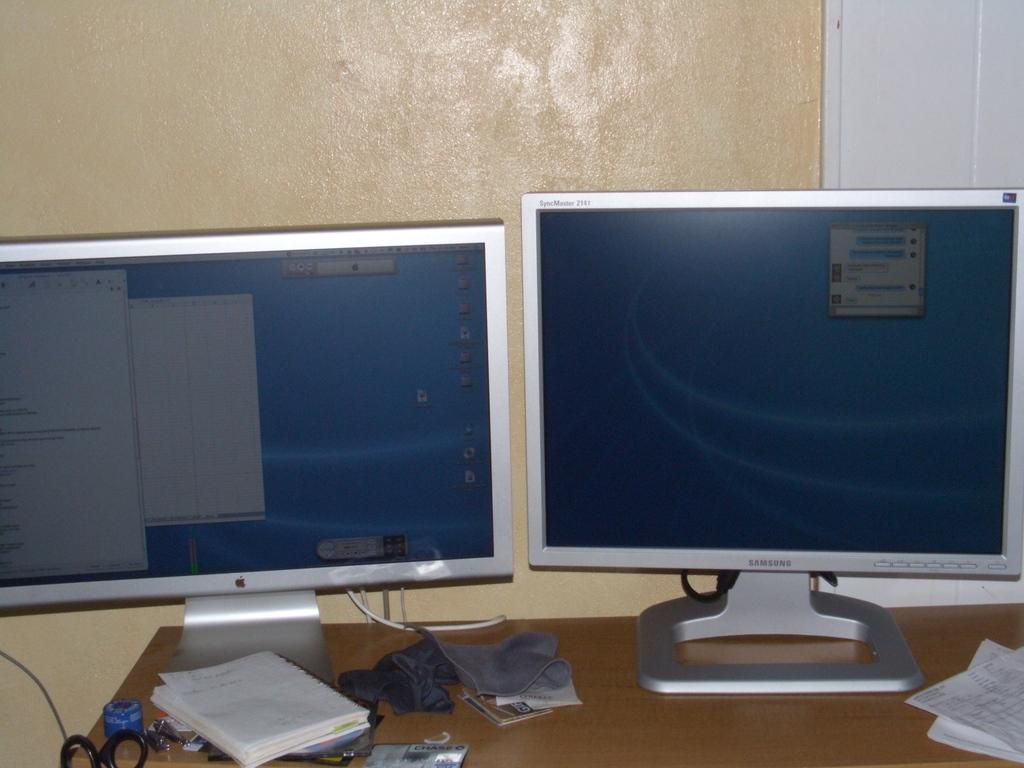<image>
Present a compact description of the photo's key features. An apple monitor and a Samsung monitor on next to each other on a desk. 